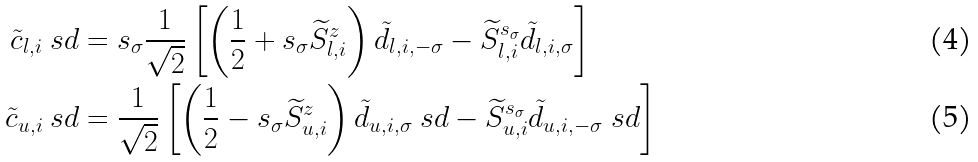Convert formula to latex. <formula><loc_0><loc_0><loc_500><loc_500>\tilde { c } _ { l , i } \ s d & = s _ { \sigma } \frac { 1 } { \sqrt { 2 } } \left [ \left ( \frac { 1 } { 2 } + s _ { \sigma } \widetilde { S } _ { l , i } ^ { z } \right ) \tilde { d } _ { l , i , - \sigma } - \widetilde { S } _ { l , i } ^ { s _ { \sigma } } \tilde { d } _ { l , i , \sigma } \right ] \\ \tilde { c } _ { u , i } \ s d & = \frac { 1 } { \sqrt { 2 } } \left [ \left ( \frac { 1 } { 2 } - s _ { \sigma } \widetilde { S } _ { u , i } ^ { z } \right ) \tilde { d } _ { u , i , \sigma } \ s d - \widetilde { S } _ { u , i } ^ { s _ { \sigma } } \tilde { d } _ { u , i , - \sigma } \ s d \right ]</formula> 